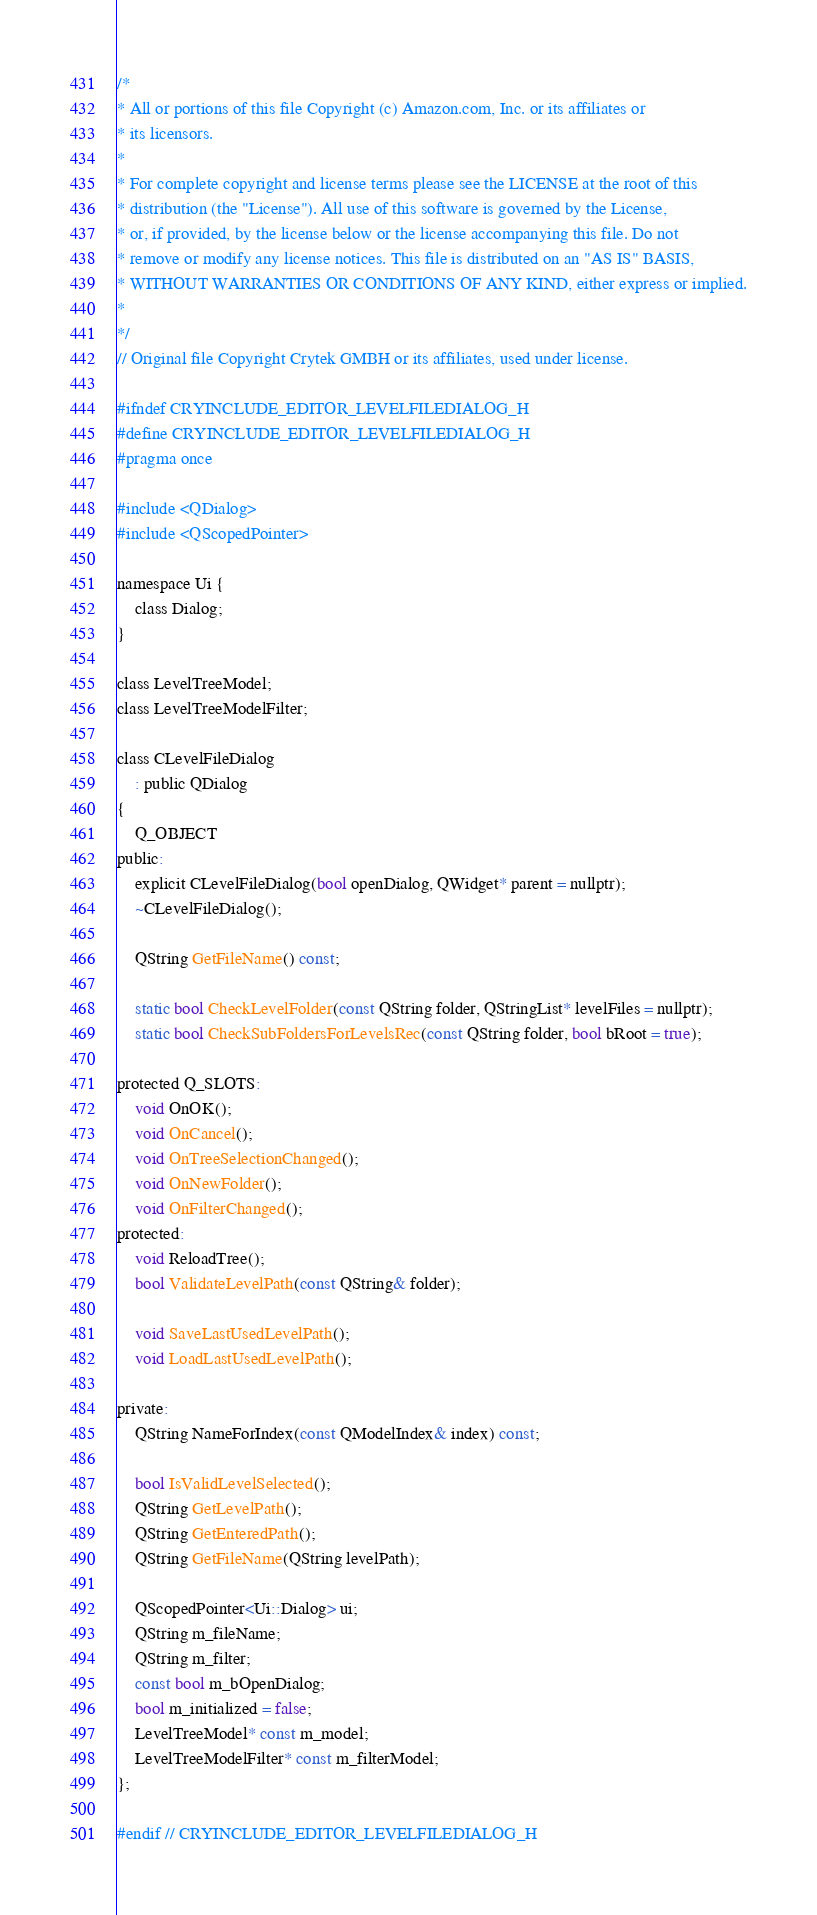<code> <loc_0><loc_0><loc_500><loc_500><_C_>/*
* All or portions of this file Copyright (c) Amazon.com, Inc. or its affiliates or
* its licensors.
*
* For complete copyright and license terms please see the LICENSE at the root of this
* distribution (the "License"). All use of this software is governed by the License,
* or, if provided, by the license below or the license accompanying this file. Do not
* remove or modify any license notices. This file is distributed on an "AS IS" BASIS,
* WITHOUT WARRANTIES OR CONDITIONS OF ANY KIND, either express or implied.
*
*/
// Original file Copyright Crytek GMBH or its affiliates, used under license.

#ifndef CRYINCLUDE_EDITOR_LEVELFILEDIALOG_H
#define CRYINCLUDE_EDITOR_LEVELFILEDIALOG_H
#pragma once

#include <QDialog>
#include <QScopedPointer>

namespace Ui {
    class Dialog;
}

class LevelTreeModel;
class LevelTreeModelFilter;

class CLevelFileDialog
    : public QDialog
{
    Q_OBJECT
public:
    explicit CLevelFileDialog(bool openDialog, QWidget* parent = nullptr);
    ~CLevelFileDialog();

    QString GetFileName() const;

    static bool CheckLevelFolder(const QString folder, QStringList* levelFiles = nullptr);
    static bool CheckSubFoldersForLevelsRec(const QString folder, bool bRoot = true);

protected Q_SLOTS:
    void OnOK();
    void OnCancel();
    void OnTreeSelectionChanged();
    void OnNewFolder();
    void OnFilterChanged();
protected:
    void ReloadTree();
    bool ValidateLevelPath(const QString& folder);

    void SaveLastUsedLevelPath();
    void LoadLastUsedLevelPath();

private:
    QString NameForIndex(const QModelIndex& index) const;

    bool IsValidLevelSelected();
    QString GetLevelPath();
    QString GetEnteredPath();
    QString GetFileName(QString levelPath);

    QScopedPointer<Ui::Dialog> ui;
    QString m_fileName;
    QString m_filter;
    const bool m_bOpenDialog;
    bool m_initialized = false;
    LevelTreeModel* const m_model;
    LevelTreeModelFilter* const m_filterModel;
};

#endif // CRYINCLUDE_EDITOR_LEVELFILEDIALOG_H
</code> 